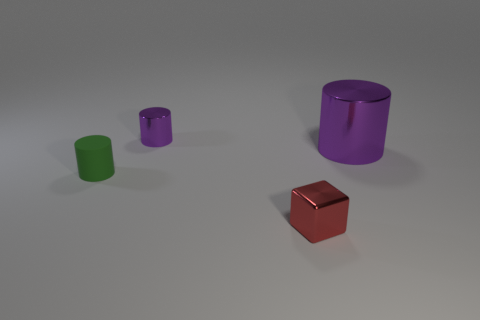Add 2 large brown matte blocks. How many objects exist? 6 Subtract all green cylinders. How many cylinders are left? 2 Subtract all green cylinders. How many cylinders are left? 2 Subtract 0 cyan balls. How many objects are left? 4 Subtract all cylinders. How many objects are left? 1 Subtract 1 blocks. How many blocks are left? 0 Subtract all green cylinders. Subtract all red spheres. How many cylinders are left? 2 Subtract all red blocks. How many green cylinders are left? 1 Subtract all purple rubber cylinders. Subtract all tiny green objects. How many objects are left? 3 Add 1 big metal cylinders. How many big metal cylinders are left? 2 